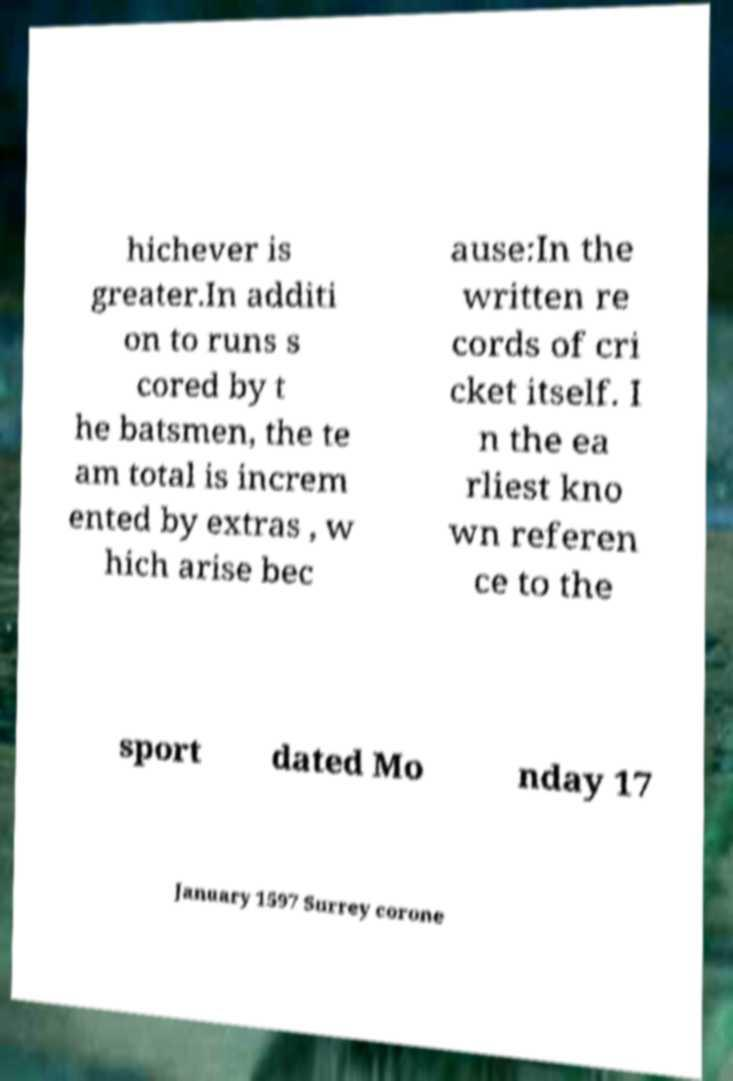Please identify and transcribe the text found in this image. hichever is greater.In additi on to runs s cored by t he batsmen, the te am total is increm ented by extras , w hich arise bec ause:In the written re cords of cri cket itself. I n the ea rliest kno wn referen ce to the sport dated Mo nday 17 January 1597 Surrey corone 